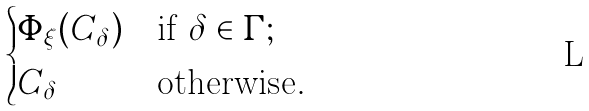<formula> <loc_0><loc_0><loc_500><loc_500>\begin{cases} \Phi _ { \xi } ( C _ { \delta } ) & \text {if } \delta \in \Gamma ; \\ C _ { \delta } & \text {otherwise} . \end{cases}</formula> 